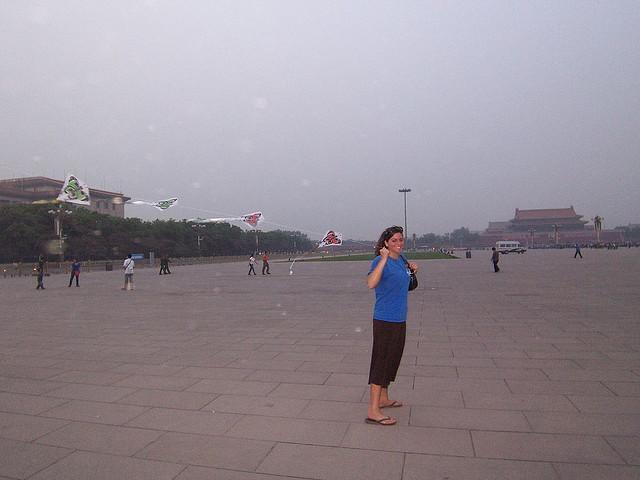How many kites are being flown?
Give a very brief answer. 4. 